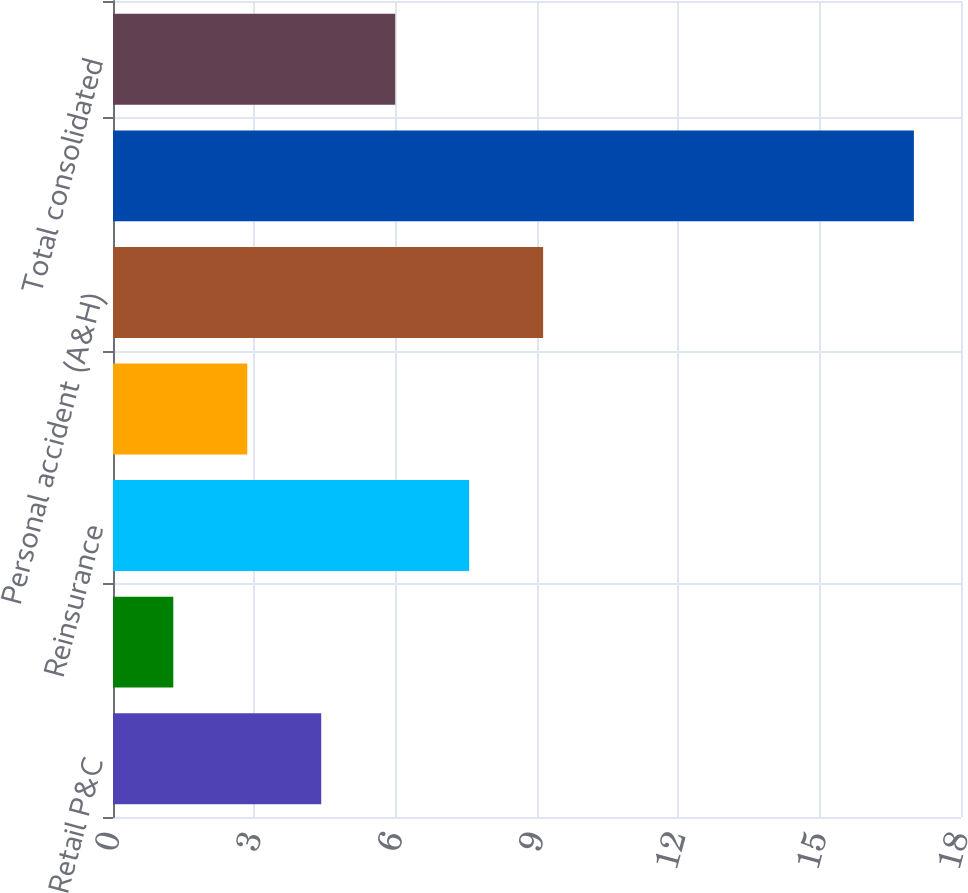Convert chart. <chart><loc_0><loc_0><loc_500><loc_500><bar_chart><fcel>Retail P&C<fcel>Wholesale<fcel>Reinsurance<fcel>Property casualty and all<fcel>Personal accident (A&H)<fcel>Life<fcel>Total consolidated<nl><fcel>4.42<fcel>1.28<fcel>7.56<fcel>2.85<fcel>9.13<fcel>17<fcel>5.99<nl></chart> 